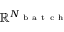<formula> <loc_0><loc_0><loc_500><loc_500>\mathbb { R } ^ { N _ { b a t c h } }</formula> 